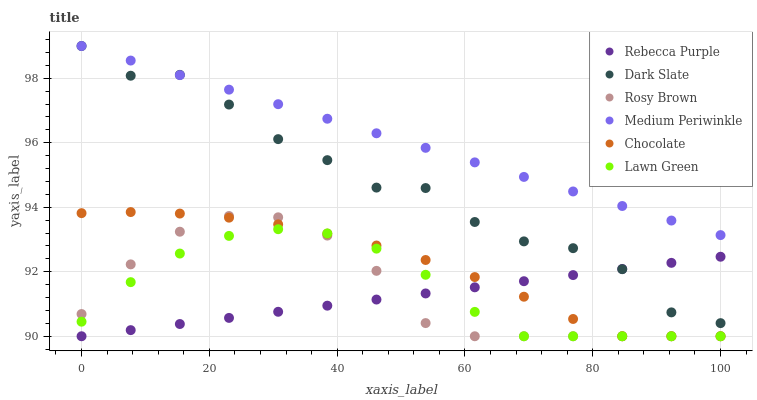Does Rebecca Purple have the minimum area under the curve?
Answer yes or no. Yes. Does Medium Periwinkle have the maximum area under the curve?
Answer yes or no. Yes. Does Rosy Brown have the minimum area under the curve?
Answer yes or no. No. Does Rosy Brown have the maximum area under the curve?
Answer yes or no. No. Is Medium Periwinkle the smoothest?
Answer yes or no. Yes. Is Dark Slate the roughest?
Answer yes or no. Yes. Is Rosy Brown the smoothest?
Answer yes or no. No. Is Rosy Brown the roughest?
Answer yes or no. No. Does Lawn Green have the lowest value?
Answer yes or no. Yes. Does Medium Periwinkle have the lowest value?
Answer yes or no. No. Does Dark Slate have the highest value?
Answer yes or no. Yes. Does Rosy Brown have the highest value?
Answer yes or no. No. Is Rosy Brown less than Dark Slate?
Answer yes or no. Yes. Is Dark Slate greater than Rosy Brown?
Answer yes or no. Yes. Does Lawn Green intersect Chocolate?
Answer yes or no. Yes. Is Lawn Green less than Chocolate?
Answer yes or no. No. Is Lawn Green greater than Chocolate?
Answer yes or no. No. Does Rosy Brown intersect Dark Slate?
Answer yes or no. No. 